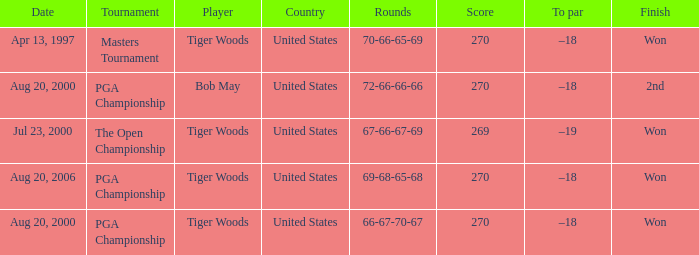What players finished 2nd? Bob May. 